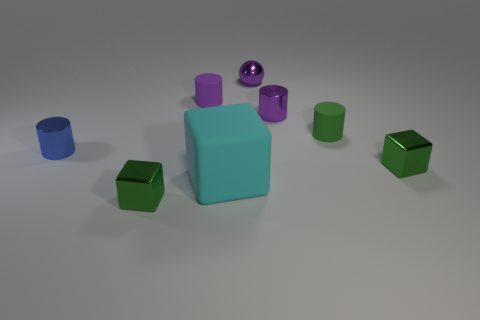Are there any other things that have the same shape as the purple matte thing? Yes, there is a green matte object that has the same cylindrical shape as the purple matte object. 